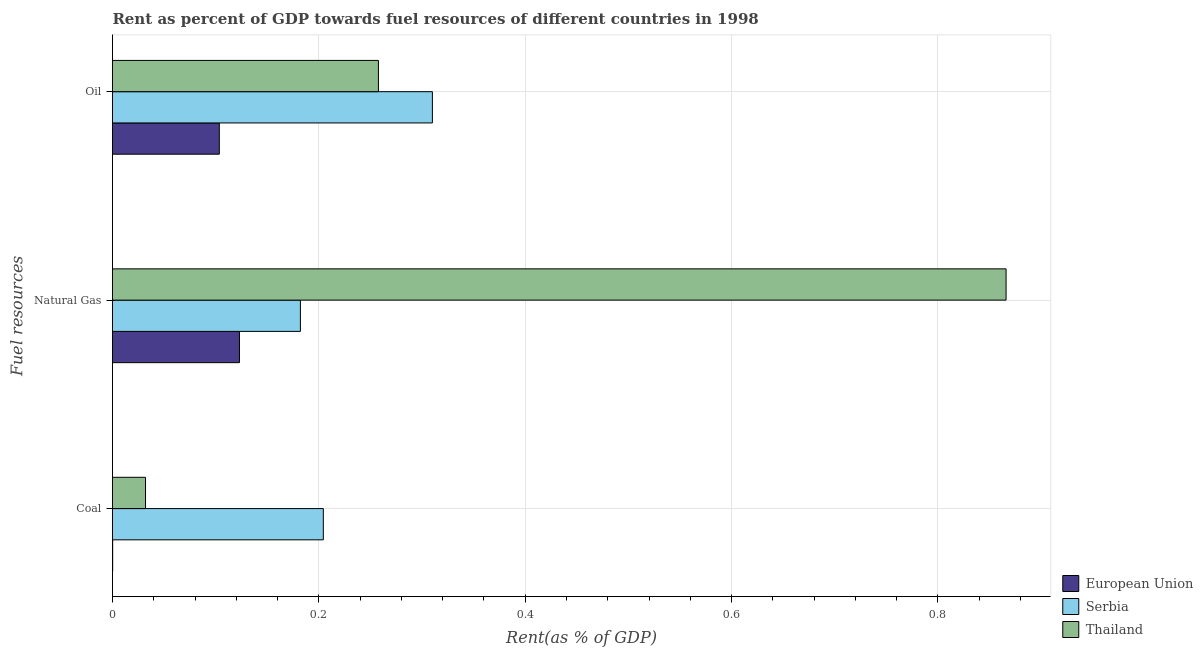Are the number of bars per tick equal to the number of legend labels?
Give a very brief answer. Yes. Are the number of bars on each tick of the Y-axis equal?
Provide a succinct answer. Yes. What is the label of the 3rd group of bars from the top?
Offer a very short reply. Coal. What is the rent towards oil in Thailand?
Provide a succinct answer. 0.26. Across all countries, what is the maximum rent towards coal?
Provide a short and direct response. 0.2. Across all countries, what is the minimum rent towards coal?
Provide a succinct answer. 0. In which country was the rent towards oil maximum?
Ensure brevity in your answer.  Serbia. What is the total rent towards oil in the graph?
Keep it short and to the point. 0.67. What is the difference between the rent towards coal in European Union and that in Thailand?
Ensure brevity in your answer.  -0.03. What is the difference between the rent towards coal in European Union and the rent towards natural gas in Serbia?
Provide a succinct answer. -0.18. What is the average rent towards coal per country?
Offer a very short reply. 0.08. What is the difference between the rent towards natural gas and rent towards coal in European Union?
Provide a short and direct response. 0.12. What is the ratio of the rent towards coal in Thailand to that in European Union?
Keep it short and to the point. 203.29. Is the rent towards coal in European Union less than that in Serbia?
Provide a short and direct response. Yes. What is the difference between the highest and the second highest rent towards oil?
Offer a very short reply. 0.05. What is the difference between the highest and the lowest rent towards oil?
Your response must be concise. 0.21. Is the sum of the rent towards natural gas in Serbia and European Union greater than the maximum rent towards oil across all countries?
Your answer should be compact. No. What does the 1st bar from the bottom in Natural Gas represents?
Offer a terse response. European Union. Is it the case that in every country, the sum of the rent towards coal and rent towards natural gas is greater than the rent towards oil?
Give a very brief answer. Yes. How many bars are there?
Your answer should be compact. 9. What is the difference between two consecutive major ticks on the X-axis?
Ensure brevity in your answer.  0.2. Does the graph contain grids?
Provide a succinct answer. Yes. Where does the legend appear in the graph?
Ensure brevity in your answer.  Bottom right. How many legend labels are there?
Your answer should be compact. 3. How are the legend labels stacked?
Your answer should be compact. Vertical. What is the title of the graph?
Ensure brevity in your answer.  Rent as percent of GDP towards fuel resources of different countries in 1998. Does "Chad" appear as one of the legend labels in the graph?
Offer a very short reply. No. What is the label or title of the X-axis?
Offer a very short reply. Rent(as % of GDP). What is the label or title of the Y-axis?
Keep it short and to the point. Fuel resources. What is the Rent(as % of GDP) of European Union in Coal?
Make the answer very short. 0. What is the Rent(as % of GDP) in Serbia in Coal?
Your response must be concise. 0.2. What is the Rent(as % of GDP) of Thailand in Coal?
Your answer should be compact. 0.03. What is the Rent(as % of GDP) of European Union in Natural Gas?
Keep it short and to the point. 0.12. What is the Rent(as % of GDP) in Serbia in Natural Gas?
Make the answer very short. 0.18. What is the Rent(as % of GDP) of Thailand in Natural Gas?
Your response must be concise. 0.87. What is the Rent(as % of GDP) in European Union in Oil?
Your response must be concise. 0.1. What is the Rent(as % of GDP) of Serbia in Oil?
Your answer should be compact. 0.31. What is the Rent(as % of GDP) in Thailand in Oil?
Offer a terse response. 0.26. Across all Fuel resources, what is the maximum Rent(as % of GDP) in European Union?
Make the answer very short. 0.12. Across all Fuel resources, what is the maximum Rent(as % of GDP) of Serbia?
Give a very brief answer. 0.31. Across all Fuel resources, what is the maximum Rent(as % of GDP) of Thailand?
Your answer should be very brief. 0.87. Across all Fuel resources, what is the minimum Rent(as % of GDP) in European Union?
Keep it short and to the point. 0. Across all Fuel resources, what is the minimum Rent(as % of GDP) of Serbia?
Make the answer very short. 0.18. Across all Fuel resources, what is the minimum Rent(as % of GDP) in Thailand?
Provide a succinct answer. 0.03. What is the total Rent(as % of GDP) in European Union in the graph?
Keep it short and to the point. 0.23. What is the total Rent(as % of GDP) of Serbia in the graph?
Provide a succinct answer. 0.7. What is the total Rent(as % of GDP) of Thailand in the graph?
Offer a very short reply. 1.16. What is the difference between the Rent(as % of GDP) in European Union in Coal and that in Natural Gas?
Your answer should be compact. -0.12. What is the difference between the Rent(as % of GDP) of Serbia in Coal and that in Natural Gas?
Offer a terse response. 0.02. What is the difference between the Rent(as % of GDP) in Thailand in Coal and that in Natural Gas?
Ensure brevity in your answer.  -0.83. What is the difference between the Rent(as % of GDP) in European Union in Coal and that in Oil?
Ensure brevity in your answer.  -0.1. What is the difference between the Rent(as % of GDP) of Serbia in Coal and that in Oil?
Offer a very short reply. -0.11. What is the difference between the Rent(as % of GDP) in Thailand in Coal and that in Oil?
Your answer should be compact. -0.23. What is the difference between the Rent(as % of GDP) in European Union in Natural Gas and that in Oil?
Make the answer very short. 0.02. What is the difference between the Rent(as % of GDP) of Serbia in Natural Gas and that in Oil?
Offer a terse response. -0.13. What is the difference between the Rent(as % of GDP) in Thailand in Natural Gas and that in Oil?
Your response must be concise. 0.61. What is the difference between the Rent(as % of GDP) in European Union in Coal and the Rent(as % of GDP) in Serbia in Natural Gas?
Your answer should be very brief. -0.18. What is the difference between the Rent(as % of GDP) of European Union in Coal and the Rent(as % of GDP) of Thailand in Natural Gas?
Give a very brief answer. -0.87. What is the difference between the Rent(as % of GDP) of Serbia in Coal and the Rent(as % of GDP) of Thailand in Natural Gas?
Your response must be concise. -0.66. What is the difference between the Rent(as % of GDP) of European Union in Coal and the Rent(as % of GDP) of Serbia in Oil?
Your answer should be compact. -0.31. What is the difference between the Rent(as % of GDP) of European Union in Coal and the Rent(as % of GDP) of Thailand in Oil?
Provide a short and direct response. -0.26. What is the difference between the Rent(as % of GDP) in Serbia in Coal and the Rent(as % of GDP) in Thailand in Oil?
Make the answer very short. -0.05. What is the difference between the Rent(as % of GDP) in European Union in Natural Gas and the Rent(as % of GDP) in Serbia in Oil?
Provide a short and direct response. -0.19. What is the difference between the Rent(as % of GDP) of European Union in Natural Gas and the Rent(as % of GDP) of Thailand in Oil?
Provide a short and direct response. -0.13. What is the difference between the Rent(as % of GDP) in Serbia in Natural Gas and the Rent(as % of GDP) in Thailand in Oil?
Offer a terse response. -0.08. What is the average Rent(as % of GDP) of European Union per Fuel resources?
Provide a short and direct response. 0.08. What is the average Rent(as % of GDP) of Serbia per Fuel resources?
Your answer should be very brief. 0.23. What is the average Rent(as % of GDP) of Thailand per Fuel resources?
Your answer should be very brief. 0.39. What is the difference between the Rent(as % of GDP) of European Union and Rent(as % of GDP) of Serbia in Coal?
Your response must be concise. -0.2. What is the difference between the Rent(as % of GDP) in European Union and Rent(as % of GDP) in Thailand in Coal?
Your answer should be compact. -0.03. What is the difference between the Rent(as % of GDP) in Serbia and Rent(as % of GDP) in Thailand in Coal?
Provide a short and direct response. 0.17. What is the difference between the Rent(as % of GDP) of European Union and Rent(as % of GDP) of Serbia in Natural Gas?
Make the answer very short. -0.06. What is the difference between the Rent(as % of GDP) of European Union and Rent(as % of GDP) of Thailand in Natural Gas?
Your answer should be compact. -0.74. What is the difference between the Rent(as % of GDP) in Serbia and Rent(as % of GDP) in Thailand in Natural Gas?
Offer a terse response. -0.68. What is the difference between the Rent(as % of GDP) in European Union and Rent(as % of GDP) in Serbia in Oil?
Make the answer very short. -0.21. What is the difference between the Rent(as % of GDP) of European Union and Rent(as % of GDP) of Thailand in Oil?
Keep it short and to the point. -0.15. What is the difference between the Rent(as % of GDP) in Serbia and Rent(as % of GDP) in Thailand in Oil?
Offer a terse response. 0.05. What is the ratio of the Rent(as % of GDP) of European Union in Coal to that in Natural Gas?
Your response must be concise. 0. What is the ratio of the Rent(as % of GDP) of Serbia in Coal to that in Natural Gas?
Keep it short and to the point. 1.12. What is the ratio of the Rent(as % of GDP) of Thailand in Coal to that in Natural Gas?
Your response must be concise. 0.04. What is the ratio of the Rent(as % of GDP) in European Union in Coal to that in Oil?
Your answer should be compact. 0. What is the ratio of the Rent(as % of GDP) of Serbia in Coal to that in Oil?
Keep it short and to the point. 0.66. What is the ratio of the Rent(as % of GDP) of Thailand in Coal to that in Oil?
Make the answer very short. 0.12. What is the ratio of the Rent(as % of GDP) in European Union in Natural Gas to that in Oil?
Ensure brevity in your answer.  1.19. What is the ratio of the Rent(as % of GDP) in Serbia in Natural Gas to that in Oil?
Provide a short and direct response. 0.59. What is the ratio of the Rent(as % of GDP) in Thailand in Natural Gas to that in Oil?
Ensure brevity in your answer.  3.36. What is the difference between the highest and the second highest Rent(as % of GDP) of European Union?
Your answer should be compact. 0.02. What is the difference between the highest and the second highest Rent(as % of GDP) of Serbia?
Your answer should be very brief. 0.11. What is the difference between the highest and the second highest Rent(as % of GDP) in Thailand?
Provide a short and direct response. 0.61. What is the difference between the highest and the lowest Rent(as % of GDP) in European Union?
Your answer should be very brief. 0.12. What is the difference between the highest and the lowest Rent(as % of GDP) of Serbia?
Offer a very short reply. 0.13. What is the difference between the highest and the lowest Rent(as % of GDP) in Thailand?
Your answer should be compact. 0.83. 